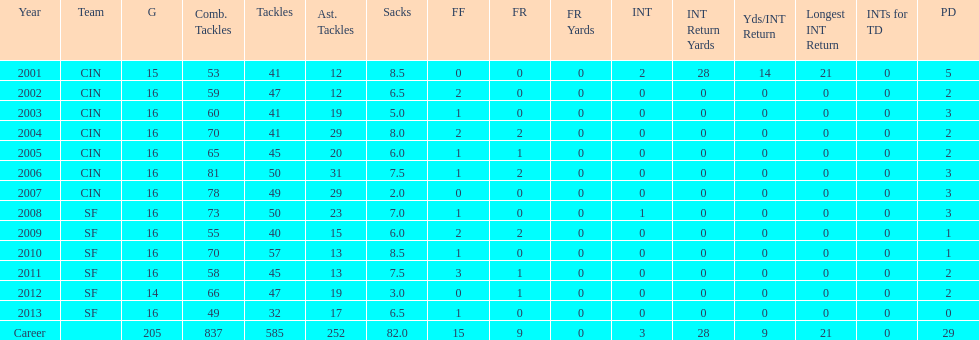Would you mind parsing the complete table? {'header': ['Year', 'Team', 'G', 'Comb. Tackles', 'Tackles', 'Ast. Tackles', 'Sacks', 'FF', 'FR', 'FR Yards', 'INT', 'INT Return Yards', 'Yds/INT Return', 'Longest INT Return', 'INTs for TD', 'PD'], 'rows': [['2001', 'CIN', '15', '53', '41', '12', '8.5', '0', '0', '0', '2', '28', '14', '21', '0', '5'], ['2002', 'CIN', '16', '59', '47', '12', '6.5', '2', '0', '0', '0', '0', '0', '0', '0', '2'], ['2003', 'CIN', '16', '60', '41', '19', '5.0', '1', '0', '0', '0', '0', '0', '0', '0', '3'], ['2004', 'CIN', '16', '70', '41', '29', '8.0', '2', '2', '0', '0', '0', '0', '0', '0', '2'], ['2005', 'CIN', '16', '65', '45', '20', '6.0', '1', '1', '0', '0', '0', '0', '0', '0', '2'], ['2006', 'CIN', '16', '81', '50', '31', '7.5', '1', '2', '0', '0', '0', '0', '0', '0', '3'], ['2007', 'CIN', '16', '78', '49', '29', '2.0', '0', '0', '0', '0', '0', '0', '0', '0', '3'], ['2008', 'SF', '16', '73', '50', '23', '7.0', '1', '0', '0', '1', '0', '0', '0', '0', '3'], ['2009', 'SF', '16', '55', '40', '15', '6.0', '2', '2', '0', '0', '0', '0', '0', '0', '1'], ['2010', 'SF', '16', '70', '57', '13', '8.5', '1', '0', '0', '0', '0', '0', '0', '0', '1'], ['2011', 'SF', '16', '58', '45', '13', '7.5', '3', '1', '0', '0', '0', '0', '0', '0', '2'], ['2012', 'SF', '14', '66', '47', '19', '3.0', '0', '1', '0', '0', '0', '0', '0', '0', '2'], ['2013', 'SF', '16', '49', '32', '17', '6.5', '1', '0', '0', '0', '0', '0', '0', '0', '0'], ['Career', '', '205', '837', '585', '252', '82.0', '15', '9', '0', '3', '28', '9', '21', '0', '29']]} What is the total number of sacks smith has made? 82.0. 